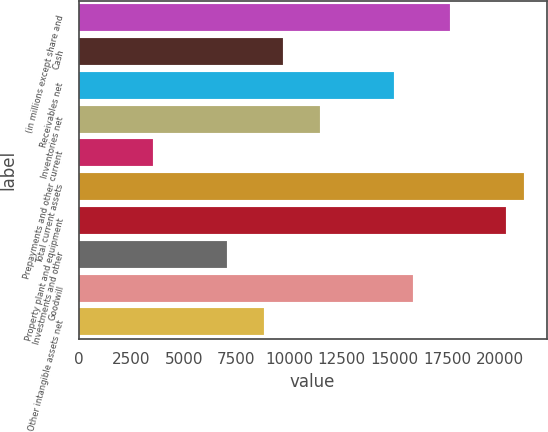<chart> <loc_0><loc_0><loc_500><loc_500><bar_chart><fcel>(in millions except share and<fcel>Cash<fcel>Receivables net<fcel>Inventories net<fcel>Prepayments and other current<fcel>Total current assets<fcel>Property plant and equipment<fcel>Investments and other<fcel>Goodwill<fcel>Other intangible assets net<nl><fcel>17648.9<fcel>9708.02<fcel>15001.9<fcel>11472.7<fcel>3531.78<fcel>21178.2<fcel>20295.9<fcel>7061.06<fcel>15884.3<fcel>8825.7<nl></chart> 